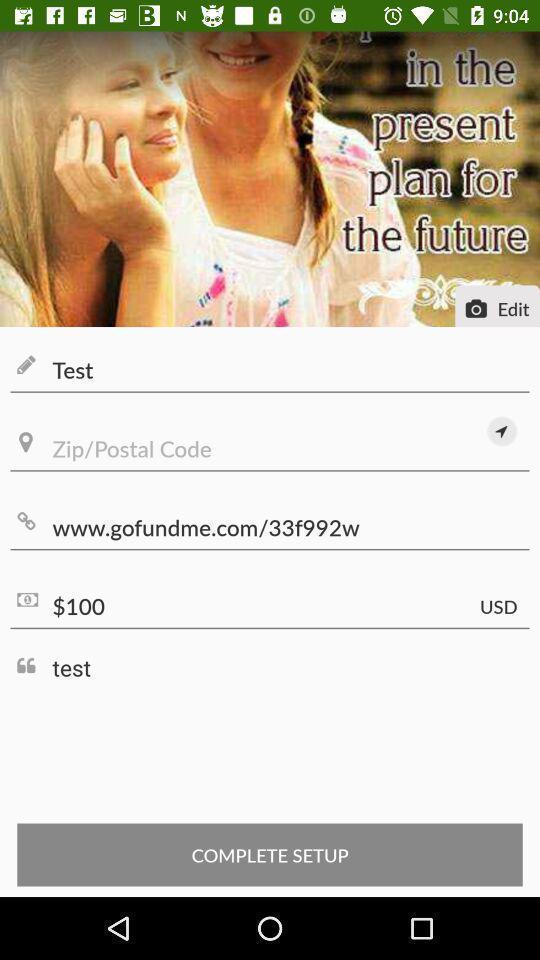What details can you identify in this image? Setup page of a fundraising app. 